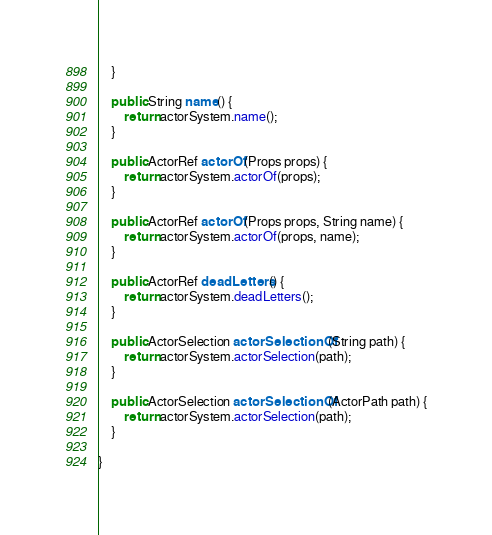Convert code to text. <code><loc_0><loc_0><loc_500><loc_500><_Java_>	}

	public String name() {
		return actorSystem.name();
	}

	public ActorRef actorOf(Props props) {
		return actorSystem.actorOf(props);
	}

	public ActorRef actorOf(Props props, String name) {
		return actorSystem.actorOf(props, name);
	}

	public ActorRef deadLetters() {
		return actorSystem.deadLetters();
	}

	public ActorSelection actorSelectionOf(String path) {
		return actorSystem.actorSelection(path);
	}

	public ActorSelection actorSelectionOf(ActorPath path) {
		return actorSystem.actorSelection(path);
	}

}
</code> 